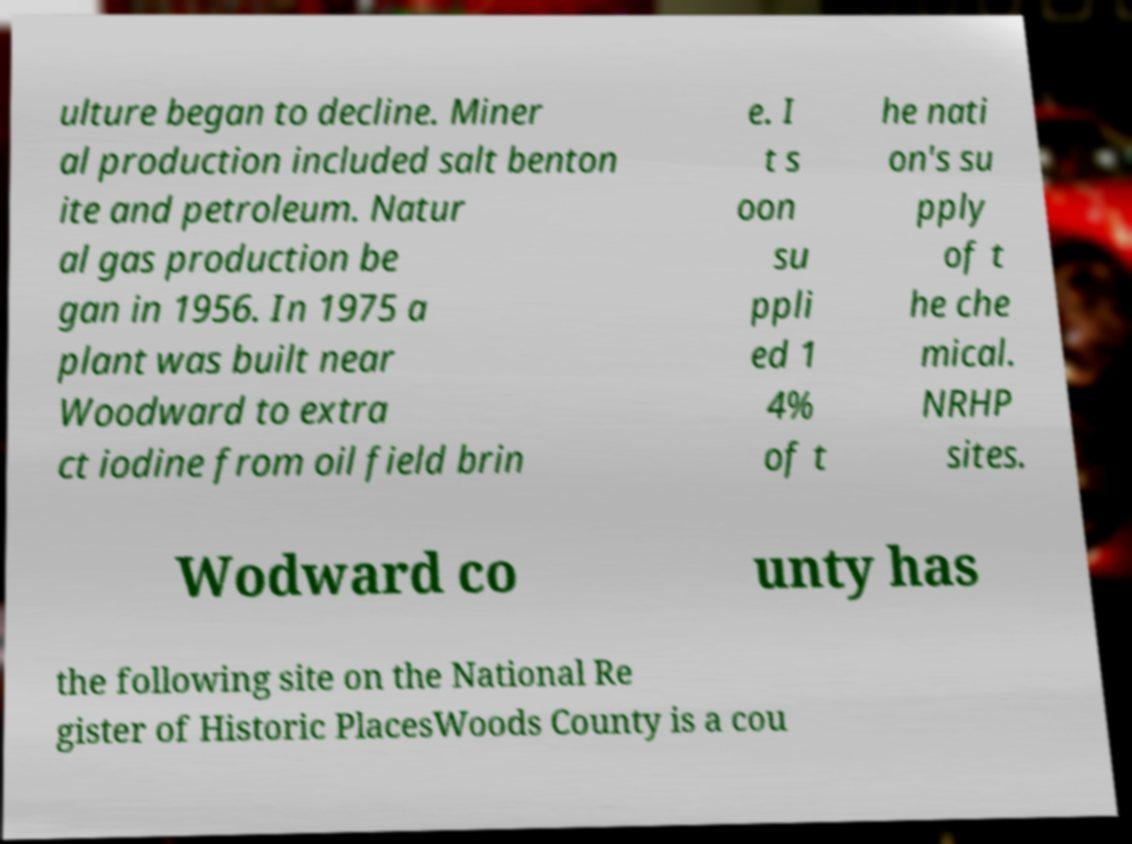Can you read and provide the text displayed in the image?This photo seems to have some interesting text. Can you extract and type it out for me? ulture began to decline. Miner al production included salt benton ite and petroleum. Natur al gas production be gan in 1956. In 1975 a plant was built near Woodward to extra ct iodine from oil field brin e. I t s oon su ppli ed 1 4% of t he nati on's su pply of t he che mical. NRHP sites. Wodward co unty has the following site on the National Re gister of Historic PlacesWoods County is a cou 